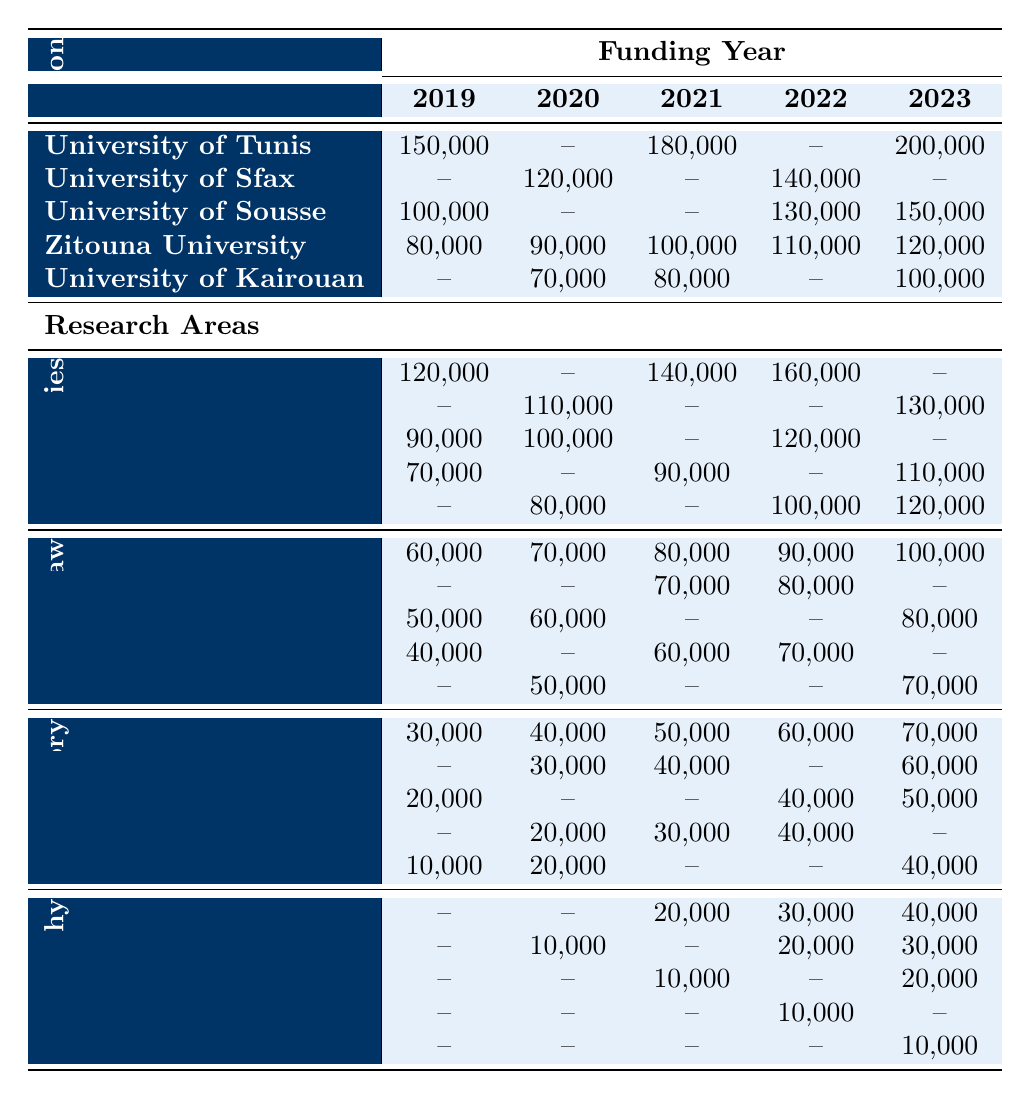What is the total funding allocated to Zitouna University from 2019 to 2023? Summing the funding values for Zitouna University: 80,000 (2019) + 90,000 (2020) + 100,000 (2021) + 110,000 (2022) + 120,000 (2023) = 500,000
Answer: 500,000 Which research area received the highest funding in 2022? Comparing the funding in 2022 across all research areas, the highest values are 160,000 for Quranic Studies and 110,000 for Islamic Philosophy. Therefore, Quranic Studies received the highest funding in 2022.
Answer: Quranic Studies Did the University of Sfax receive any funding in 2019? Looking at the funding row for University of Sfax, it shows a value of "--" for 2019, indicating no funding was allocated.
Answer: No What is the average funding received by the University of Kairouan from 2019 to 2023? Adding the funding values: 70,000 (2020) + 80,000 (2021) + 100,000 (2023) = 250,000. The number of years with funding is 3, so the average is 250,000 / 3 ≈ 83,333.33.
Answer: 83,333.33 How much more funding did the University of Tunis receive in 2023 compared to 2020? The funding for University of Tunis in 2023 is 200,000, and in 2020 is 0. Thus, 200,000 - 0 = 200,000.
Answer: 200,000 Which research area had the lowest total funding from 2019 to 2023? Summing the funding for each research area: Islamic History (sum = 250,000), Islamic Law (sum = 300,000), Quranic Studies (sum = 620,000), and Islamic Philosophy (sum = 100,000). Islamic Philosophy has the lowest total funding of 100,000.
Answer: Islamic Philosophy In which year did the total funding for Islamic Philosophy reach at least 30,000? The funding values for Islamic Philosophy are: 0, 0, 20000, 30000, 40000. The year 2023 is when it reached 30,000, and all subsequent years surpass that value as well.
Answer: 2022 What percentage of the total funding for Islamic Law from 2019 to 2023 was received in 2023? For Islamic Law, total funding is 60,000 + 70,000 + 80,000 + 90,000 + 100,000 = 400,000. The funding in 2023 is 100,000. Then, (100,000 / 400,000) * 100 = 25%.
Answer: 25% How does the funding trend for Quranic Studies compare with the trend for Islamic History over the years? Observing both trends: Quranic Studies shows increases from 120,000 (2019) to 160,000 (2022) and then stable until 2023, while Islamic History fluctuates but generally shows an increasing tendency, rising from 30,000 (2019) to 70,000 (2023).
Answer: Quranic Studies increases, Islamic History fluctuates but trends up Which institution consistently received funding for the most years between 2019 and 2023? Checking institutions for funded years: Zitouna University received funding every year (5 years), while others received funding in fewer years: University of Tunis (3), University of Sfax (2), University of Sousse (3), and University of Kairouan (3).
Answer: Zitouna University 